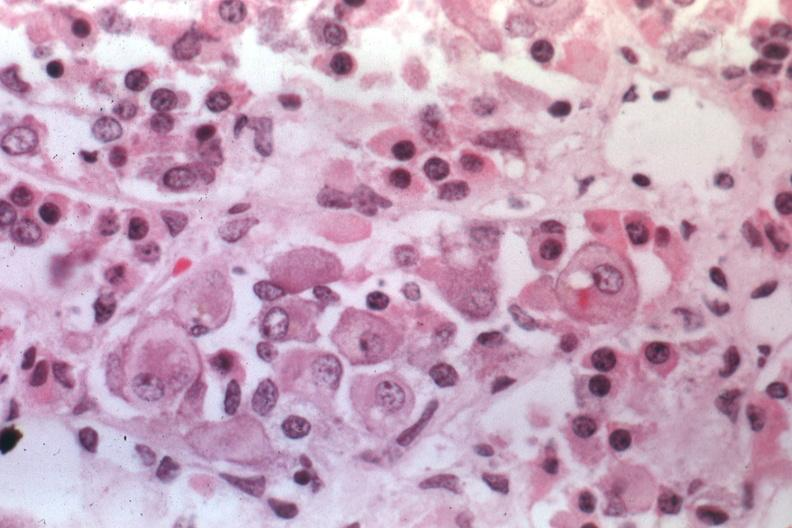s pituitary present?
Answer the question using a single word or phrase. Yes 